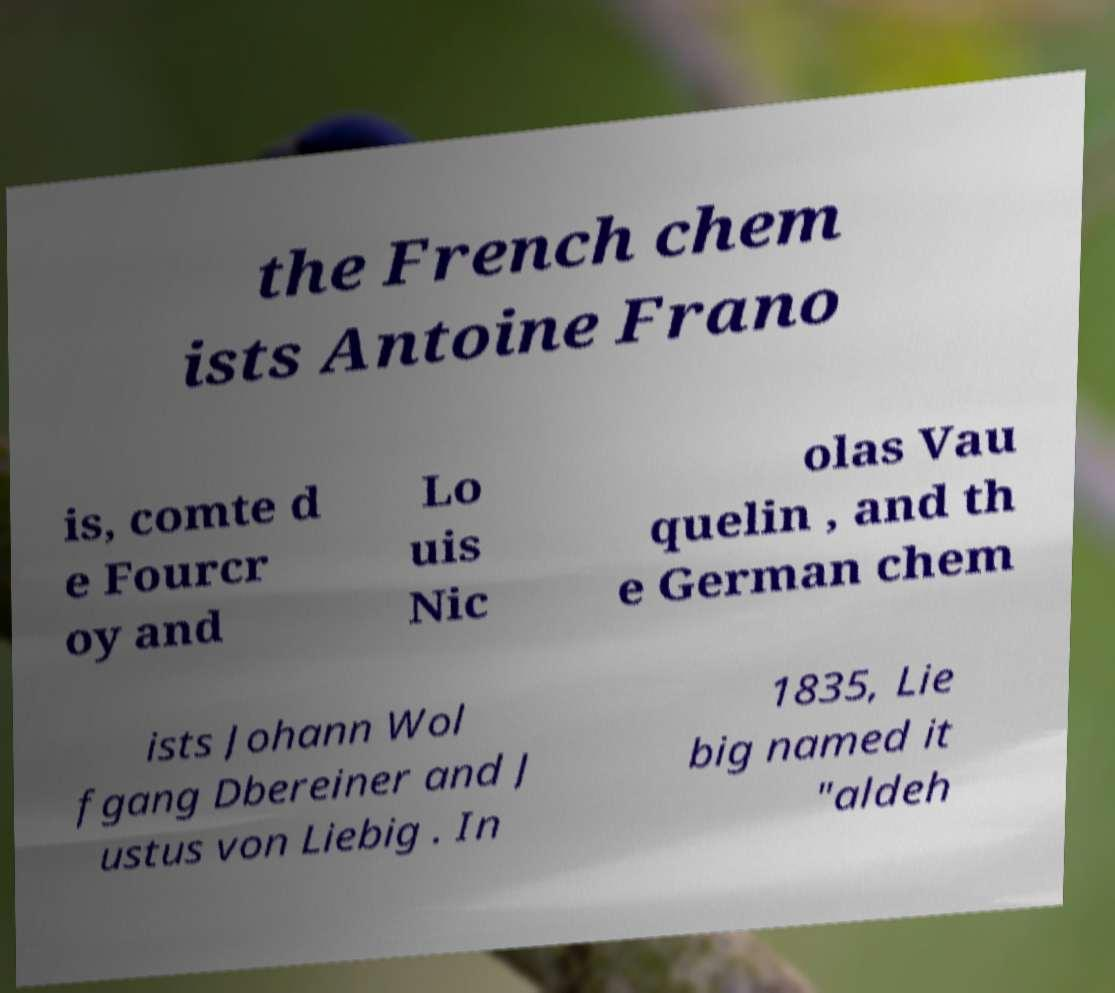What messages or text are displayed in this image? I need them in a readable, typed format. the French chem ists Antoine Frano is, comte d e Fourcr oy and Lo uis Nic olas Vau quelin , and th e German chem ists Johann Wol fgang Dbereiner and J ustus von Liebig . In 1835, Lie big named it "aldeh 